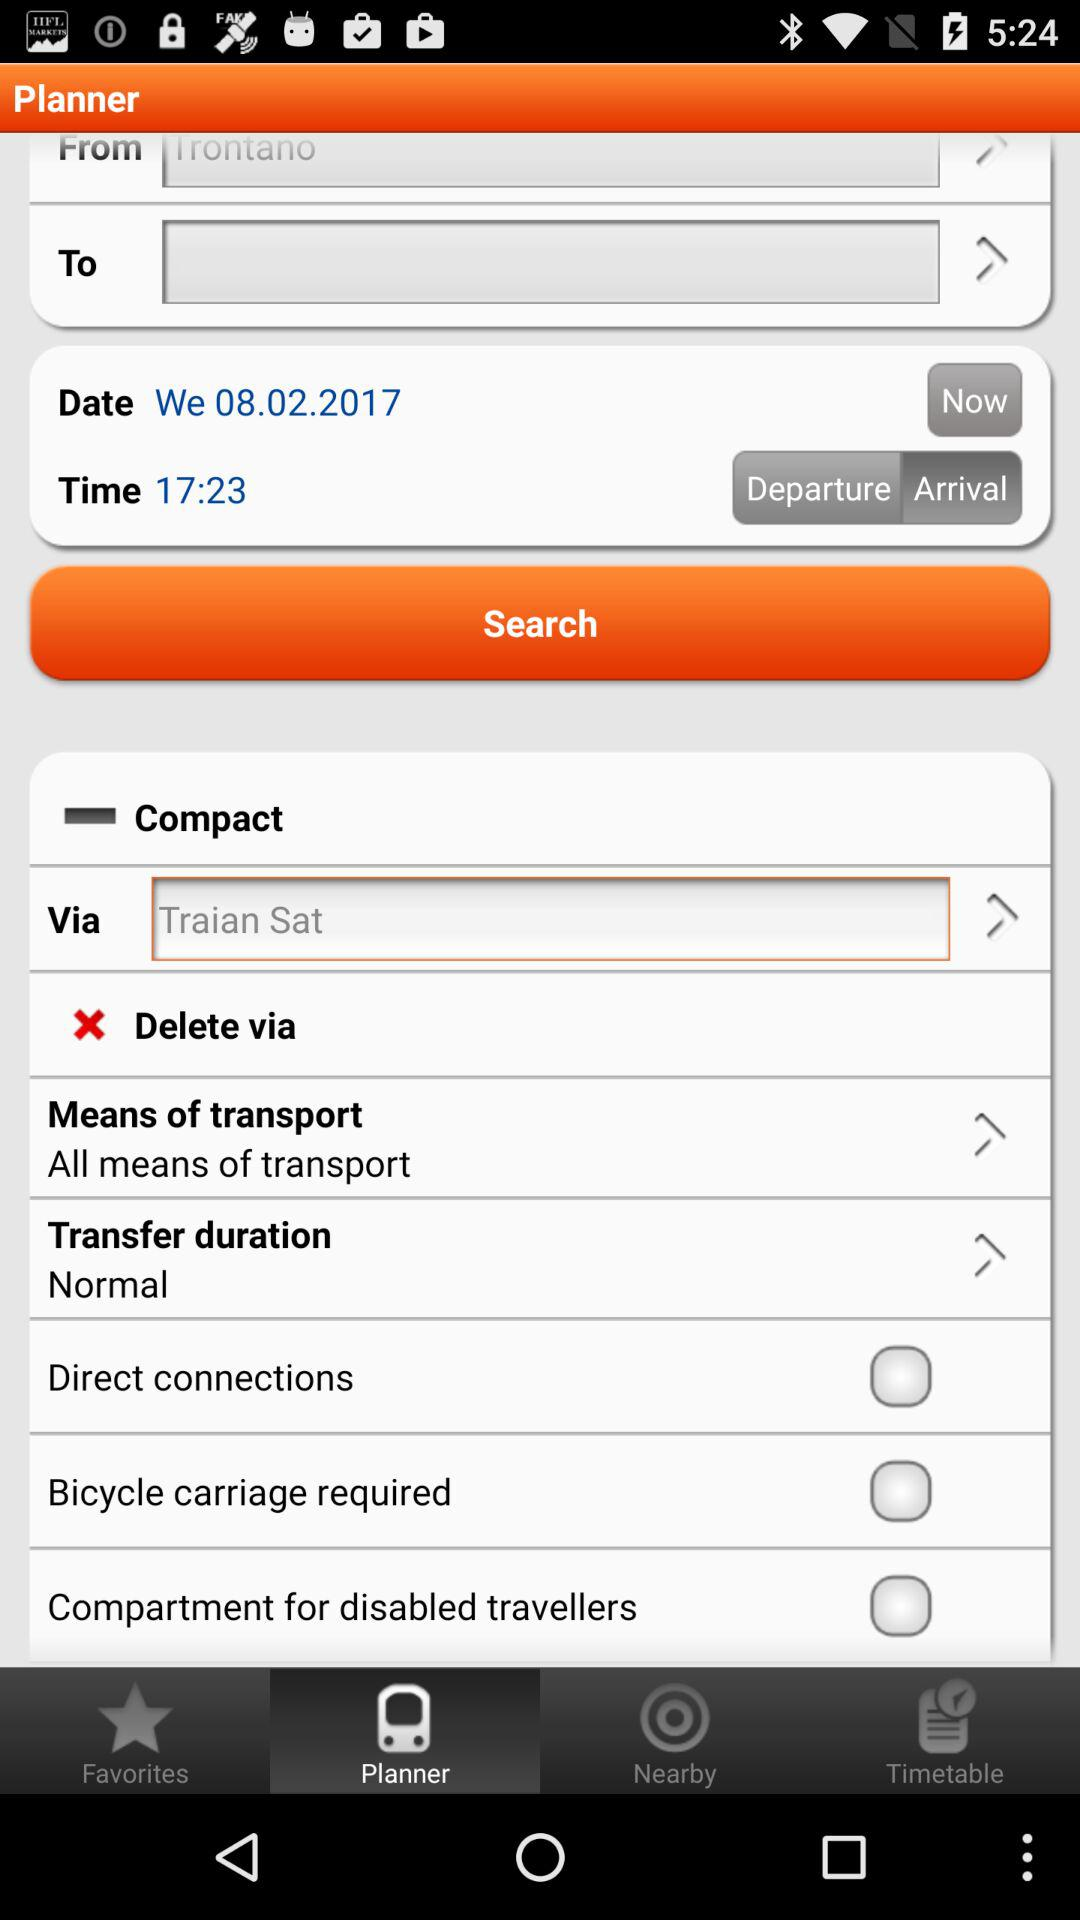What is the given time? The given time is 17:23. 